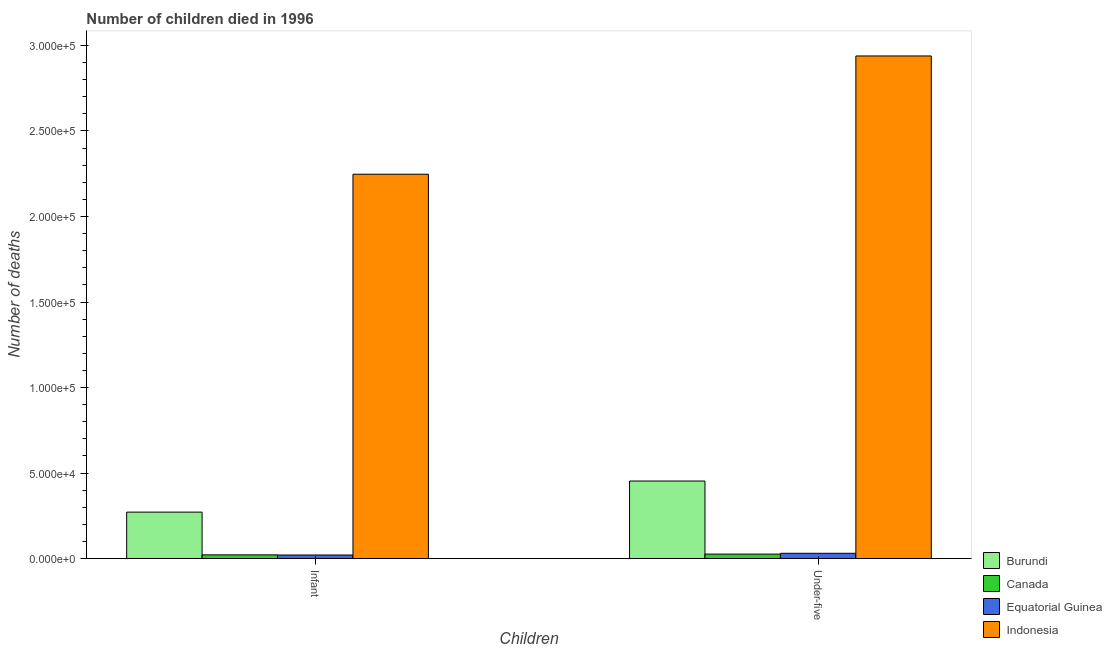How many groups of bars are there?
Give a very brief answer. 2. What is the label of the 2nd group of bars from the left?
Provide a short and direct response. Under-five. What is the number of under-five deaths in Burundi?
Ensure brevity in your answer.  4.53e+04. Across all countries, what is the maximum number of infant deaths?
Your answer should be very brief. 2.25e+05. Across all countries, what is the minimum number of under-five deaths?
Ensure brevity in your answer.  2610. In which country was the number of under-five deaths maximum?
Offer a terse response. Indonesia. In which country was the number of infant deaths minimum?
Give a very brief answer. Equatorial Guinea. What is the total number of under-five deaths in the graph?
Make the answer very short. 3.45e+05. What is the difference between the number of under-five deaths in Canada and that in Equatorial Guinea?
Make the answer very short. -474. What is the difference between the number of infant deaths in Burundi and the number of under-five deaths in Indonesia?
Your answer should be very brief. -2.67e+05. What is the average number of under-five deaths per country?
Offer a very short reply. 8.62e+04. What is the difference between the number of under-five deaths and number of infant deaths in Canada?
Keep it short and to the point. 441. What is the ratio of the number of under-five deaths in Canada to that in Equatorial Guinea?
Keep it short and to the point. 0.85. Is the number of infant deaths in Burundi less than that in Equatorial Guinea?
Your answer should be very brief. No. In how many countries, is the number of infant deaths greater than the average number of infant deaths taken over all countries?
Offer a very short reply. 1. What does the 2nd bar from the right in Infant represents?
Offer a very short reply. Equatorial Guinea. How many countries are there in the graph?
Give a very brief answer. 4. What is the difference between two consecutive major ticks on the Y-axis?
Your response must be concise. 5.00e+04. Are the values on the major ticks of Y-axis written in scientific E-notation?
Keep it short and to the point. Yes. How many legend labels are there?
Keep it short and to the point. 4. What is the title of the graph?
Provide a succinct answer. Number of children died in 1996. Does "Bahrain" appear as one of the legend labels in the graph?
Provide a short and direct response. No. What is the label or title of the X-axis?
Give a very brief answer. Children. What is the label or title of the Y-axis?
Provide a short and direct response. Number of deaths. What is the Number of deaths in Burundi in Infant?
Give a very brief answer. 2.72e+04. What is the Number of deaths in Canada in Infant?
Keep it short and to the point. 2169. What is the Number of deaths of Equatorial Guinea in Infant?
Keep it short and to the point. 2086. What is the Number of deaths in Indonesia in Infant?
Your answer should be compact. 2.25e+05. What is the Number of deaths in Burundi in Under-five?
Provide a short and direct response. 4.53e+04. What is the Number of deaths of Canada in Under-five?
Offer a terse response. 2610. What is the Number of deaths in Equatorial Guinea in Under-five?
Ensure brevity in your answer.  3084. What is the Number of deaths of Indonesia in Under-five?
Your answer should be very brief. 2.94e+05. Across all Children, what is the maximum Number of deaths of Burundi?
Make the answer very short. 4.53e+04. Across all Children, what is the maximum Number of deaths in Canada?
Your answer should be compact. 2610. Across all Children, what is the maximum Number of deaths in Equatorial Guinea?
Ensure brevity in your answer.  3084. Across all Children, what is the maximum Number of deaths of Indonesia?
Make the answer very short. 2.94e+05. Across all Children, what is the minimum Number of deaths in Burundi?
Offer a very short reply. 2.72e+04. Across all Children, what is the minimum Number of deaths of Canada?
Your response must be concise. 2169. Across all Children, what is the minimum Number of deaths of Equatorial Guinea?
Give a very brief answer. 2086. Across all Children, what is the minimum Number of deaths of Indonesia?
Provide a succinct answer. 2.25e+05. What is the total Number of deaths in Burundi in the graph?
Your answer should be compact. 7.25e+04. What is the total Number of deaths of Canada in the graph?
Give a very brief answer. 4779. What is the total Number of deaths in Equatorial Guinea in the graph?
Give a very brief answer. 5170. What is the total Number of deaths of Indonesia in the graph?
Give a very brief answer. 5.19e+05. What is the difference between the Number of deaths of Burundi in Infant and that in Under-five?
Your answer should be compact. -1.82e+04. What is the difference between the Number of deaths in Canada in Infant and that in Under-five?
Your answer should be compact. -441. What is the difference between the Number of deaths in Equatorial Guinea in Infant and that in Under-five?
Provide a succinct answer. -998. What is the difference between the Number of deaths in Indonesia in Infant and that in Under-five?
Provide a succinct answer. -6.91e+04. What is the difference between the Number of deaths of Burundi in Infant and the Number of deaths of Canada in Under-five?
Offer a terse response. 2.45e+04. What is the difference between the Number of deaths in Burundi in Infant and the Number of deaths in Equatorial Guinea in Under-five?
Your answer should be very brief. 2.41e+04. What is the difference between the Number of deaths in Burundi in Infant and the Number of deaths in Indonesia in Under-five?
Your answer should be compact. -2.67e+05. What is the difference between the Number of deaths of Canada in Infant and the Number of deaths of Equatorial Guinea in Under-five?
Ensure brevity in your answer.  -915. What is the difference between the Number of deaths of Canada in Infant and the Number of deaths of Indonesia in Under-five?
Your answer should be compact. -2.92e+05. What is the difference between the Number of deaths of Equatorial Guinea in Infant and the Number of deaths of Indonesia in Under-five?
Your answer should be very brief. -2.92e+05. What is the average Number of deaths of Burundi per Children?
Provide a short and direct response. 3.62e+04. What is the average Number of deaths in Canada per Children?
Give a very brief answer. 2389.5. What is the average Number of deaths of Equatorial Guinea per Children?
Provide a succinct answer. 2585. What is the average Number of deaths in Indonesia per Children?
Your answer should be very brief. 2.59e+05. What is the difference between the Number of deaths in Burundi and Number of deaths in Canada in Infant?
Offer a very short reply. 2.50e+04. What is the difference between the Number of deaths in Burundi and Number of deaths in Equatorial Guinea in Infant?
Your answer should be compact. 2.51e+04. What is the difference between the Number of deaths in Burundi and Number of deaths in Indonesia in Infant?
Ensure brevity in your answer.  -1.98e+05. What is the difference between the Number of deaths of Canada and Number of deaths of Indonesia in Infant?
Make the answer very short. -2.23e+05. What is the difference between the Number of deaths in Equatorial Guinea and Number of deaths in Indonesia in Infant?
Make the answer very short. -2.23e+05. What is the difference between the Number of deaths in Burundi and Number of deaths in Canada in Under-five?
Make the answer very short. 4.27e+04. What is the difference between the Number of deaths in Burundi and Number of deaths in Equatorial Guinea in Under-five?
Your answer should be very brief. 4.23e+04. What is the difference between the Number of deaths in Burundi and Number of deaths in Indonesia in Under-five?
Give a very brief answer. -2.49e+05. What is the difference between the Number of deaths in Canada and Number of deaths in Equatorial Guinea in Under-five?
Provide a succinct answer. -474. What is the difference between the Number of deaths of Canada and Number of deaths of Indonesia in Under-five?
Your answer should be very brief. -2.91e+05. What is the difference between the Number of deaths in Equatorial Guinea and Number of deaths in Indonesia in Under-five?
Make the answer very short. -2.91e+05. What is the ratio of the Number of deaths in Burundi in Infant to that in Under-five?
Offer a very short reply. 0.6. What is the ratio of the Number of deaths of Canada in Infant to that in Under-five?
Keep it short and to the point. 0.83. What is the ratio of the Number of deaths of Equatorial Guinea in Infant to that in Under-five?
Make the answer very short. 0.68. What is the ratio of the Number of deaths in Indonesia in Infant to that in Under-five?
Make the answer very short. 0.76. What is the difference between the highest and the second highest Number of deaths in Burundi?
Provide a short and direct response. 1.82e+04. What is the difference between the highest and the second highest Number of deaths of Canada?
Your answer should be very brief. 441. What is the difference between the highest and the second highest Number of deaths in Equatorial Guinea?
Offer a terse response. 998. What is the difference between the highest and the second highest Number of deaths in Indonesia?
Provide a succinct answer. 6.91e+04. What is the difference between the highest and the lowest Number of deaths of Burundi?
Provide a succinct answer. 1.82e+04. What is the difference between the highest and the lowest Number of deaths of Canada?
Your answer should be very brief. 441. What is the difference between the highest and the lowest Number of deaths in Equatorial Guinea?
Keep it short and to the point. 998. What is the difference between the highest and the lowest Number of deaths of Indonesia?
Provide a succinct answer. 6.91e+04. 